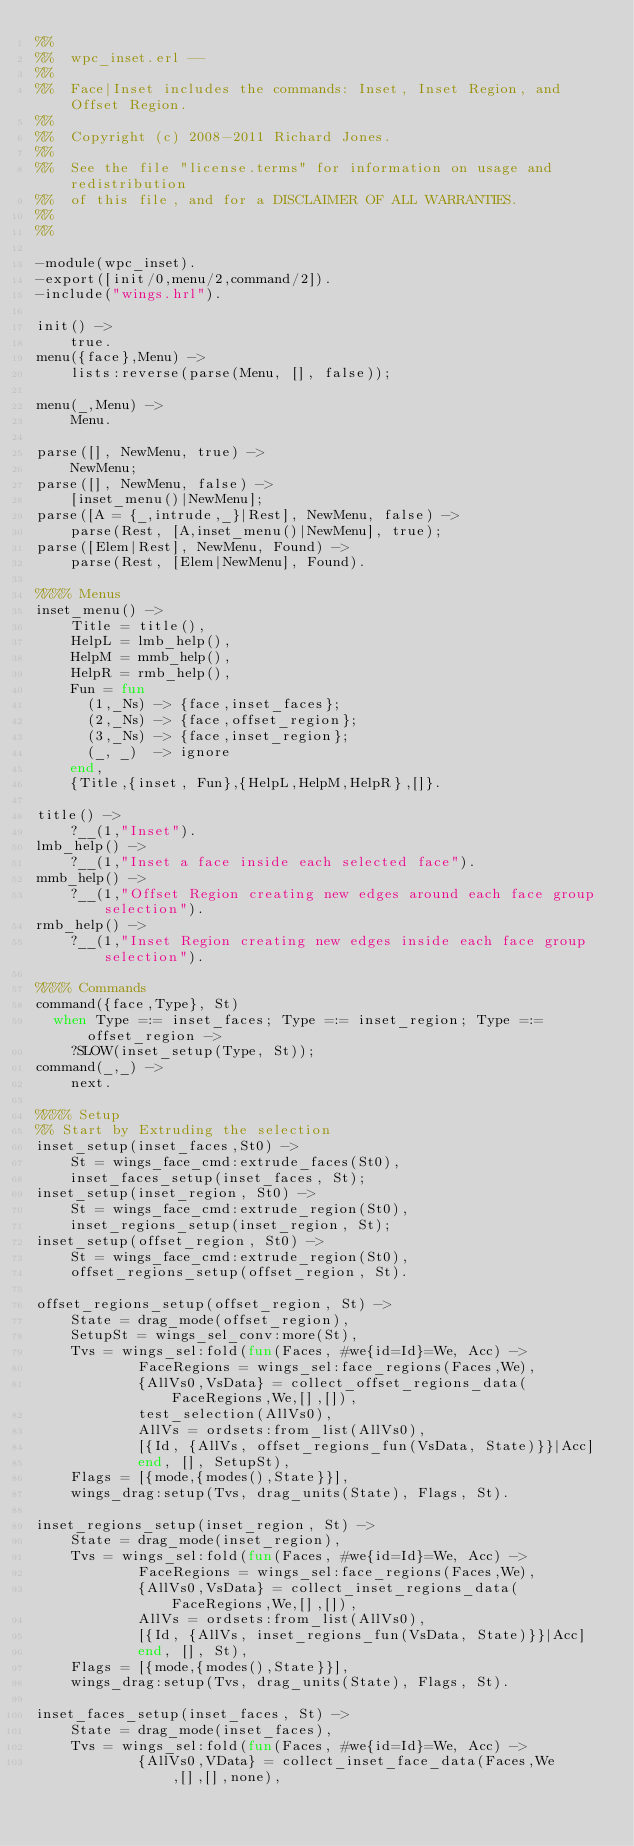<code> <loc_0><loc_0><loc_500><loc_500><_Erlang_>%%
%%  wpc_inset.erl --
%%
%%  Face|Inset includes the commands: Inset, Inset Region, and Offset Region.
%%
%%  Copyright (c) 2008-2011 Richard Jones.
%%
%%  See the file "license.terms" for information on usage and redistribution
%%  of this file, and for a DISCLAIMER OF ALL WARRANTIES.
%%
%%

-module(wpc_inset).
-export([init/0,menu/2,command/2]).
-include("wings.hrl").

init() ->
    true.
menu({face},Menu) ->
    lists:reverse(parse(Menu, [], false));

menu(_,Menu) ->
    Menu.

parse([], NewMenu, true) ->
    NewMenu;
parse([], NewMenu, false) ->
    [inset_menu()|NewMenu];
parse([A = {_,intrude,_}|Rest], NewMenu, false) ->
    parse(Rest, [A,inset_menu()|NewMenu], true);
parse([Elem|Rest], NewMenu, Found) ->
    parse(Rest, [Elem|NewMenu], Found).

%%%% Menus
inset_menu() ->
    Title = title(),
    HelpL = lmb_help(),
    HelpM = mmb_help(),
    HelpR = rmb_help(),
    Fun = fun
      (1,_Ns) -> {face,inset_faces};
      (2,_Ns) -> {face,offset_region};
      (3,_Ns) -> {face,inset_region};
      (_, _)  -> ignore
    end,
    {Title,{inset, Fun},{HelpL,HelpM,HelpR},[]}.

title() ->
    ?__(1,"Inset").
lmb_help() ->
    ?__(1,"Inset a face inside each selected face").
mmb_help() ->
    ?__(1,"Offset Region creating new edges around each face group selection").
rmb_help() ->
    ?__(1,"Inset Region creating new edges inside each face group selection").

%%%% Commands
command({face,Type}, St)
  when Type =:= inset_faces; Type =:= inset_region; Type =:= offset_region ->
    ?SLOW(inset_setup(Type, St));
command(_,_) ->
    next.

%%%% Setup
%% Start by Extruding the selection
inset_setup(inset_faces,St0) ->
    St = wings_face_cmd:extrude_faces(St0),
    inset_faces_setup(inset_faces, St);
inset_setup(inset_region, St0) ->
    St = wings_face_cmd:extrude_region(St0),
    inset_regions_setup(inset_region, St);
inset_setup(offset_region, St0) ->
    St = wings_face_cmd:extrude_region(St0),
    offset_regions_setup(offset_region, St).

offset_regions_setup(offset_region, St) ->
    State = drag_mode(offset_region),
    SetupSt = wings_sel_conv:more(St),
    Tvs = wings_sel:fold(fun(Faces, #we{id=Id}=We, Acc) ->
            FaceRegions = wings_sel:face_regions(Faces,We),
            {AllVs0,VsData} = collect_offset_regions_data(FaceRegions,We,[],[]),
            test_selection(AllVs0),
            AllVs = ordsets:from_list(AllVs0),
            [{Id, {AllVs, offset_regions_fun(VsData, State)}}|Acc]
            end, [], SetupSt),
    Flags = [{mode,{modes(),State}}],
    wings_drag:setup(Tvs, drag_units(State), Flags, St).

inset_regions_setup(inset_region, St) ->
    State = drag_mode(inset_region),
    Tvs = wings_sel:fold(fun(Faces, #we{id=Id}=We, Acc) ->
            FaceRegions = wings_sel:face_regions(Faces,We),
            {AllVs0,VsData} = collect_inset_regions_data(FaceRegions,We,[],[]),
            AllVs = ordsets:from_list(AllVs0),
            [{Id, {AllVs, inset_regions_fun(VsData, State)}}|Acc]
            end, [], St),
    Flags = [{mode,{modes(),State}}],
    wings_drag:setup(Tvs, drag_units(State), Flags, St).

inset_faces_setup(inset_faces, St) ->
    State = drag_mode(inset_faces),
    Tvs = wings_sel:fold(fun(Faces, #we{id=Id}=We, Acc) ->
            {AllVs0,VData} = collect_inset_face_data(Faces,We,[],[],none),</code> 